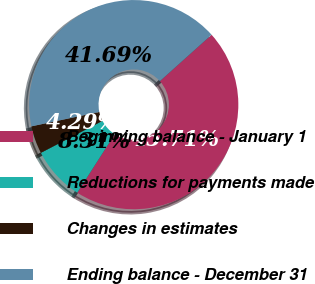Convert chart to OTSL. <chart><loc_0><loc_0><loc_500><loc_500><pie_chart><fcel>Beginning balance - January 1<fcel>Reductions for payments made<fcel>Changes in estimates<fcel>Ending balance - December 31<nl><fcel>45.71%<fcel>8.31%<fcel>4.29%<fcel>41.69%<nl></chart> 